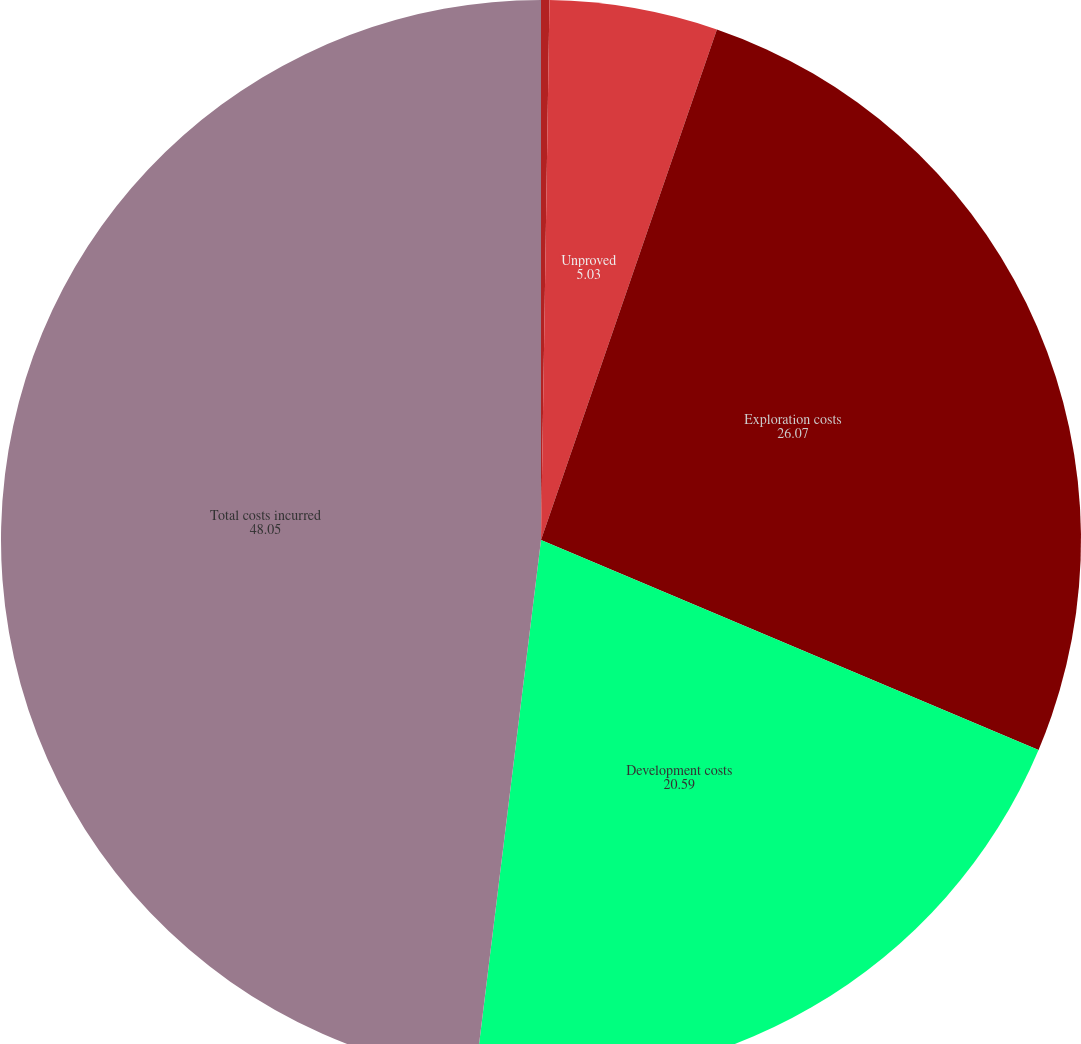<chart> <loc_0><loc_0><loc_500><loc_500><pie_chart><fcel>Proved<fcel>Unproved<fcel>Exploration costs<fcel>Development costs<fcel>Total costs incurred<nl><fcel>0.25%<fcel>5.03%<fcel>26.07%<fcel>20.59%<fcel>48.05%<nl></chart> 